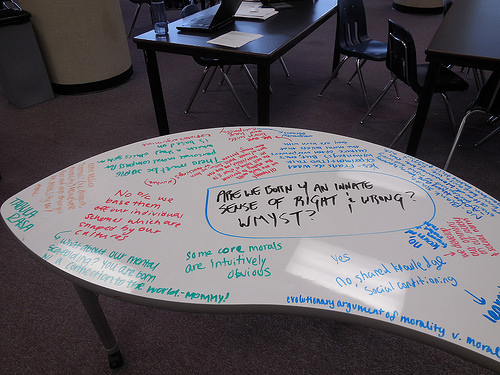<image>
Can you confirm if the glass is above the floor? Yes. The glass is positioned above the floor in the vertical space, higher up in the scene. 